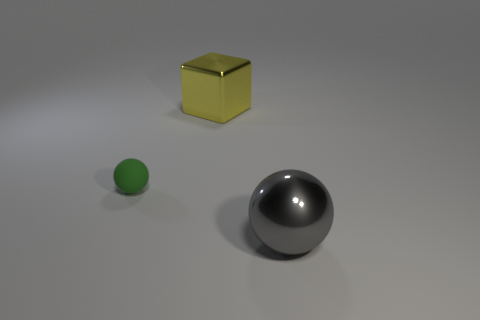Are any small yellow shiny things visible?
Make the answer very short. No. There is a yellow metal object; is it the same shape as the gray object that is to the right of the green object?
Ensure brevity in your answer.  No. The sphere that is in front of the ball on the left side of the large yellow thing is made of what material?
Make the answer very short. Metal. The tiny object has what color?
Ensure brevity in your answer.  Green. Does the thing that is in front of the tiny sphere have the same color as the ball left of the big yellow block?
Offer a terse response. No. What is the size of the shiny thing that is the same shape as the green rubber thing?
Keep it short and to the point. Large. Are there any other big metal blocks that have the same color as the large metal cube?
Your answer should be very brief. No. How many other tiny objects have the same color as the rubber thing?
Keep it short and to the point. 0. What number of things are either balls to the right of the green sphere or large metal blocks?
Your answer should be compact. 2. What is the color of the object that is the same material as the big gray ball?
Your answer should be compact. Yellow. 